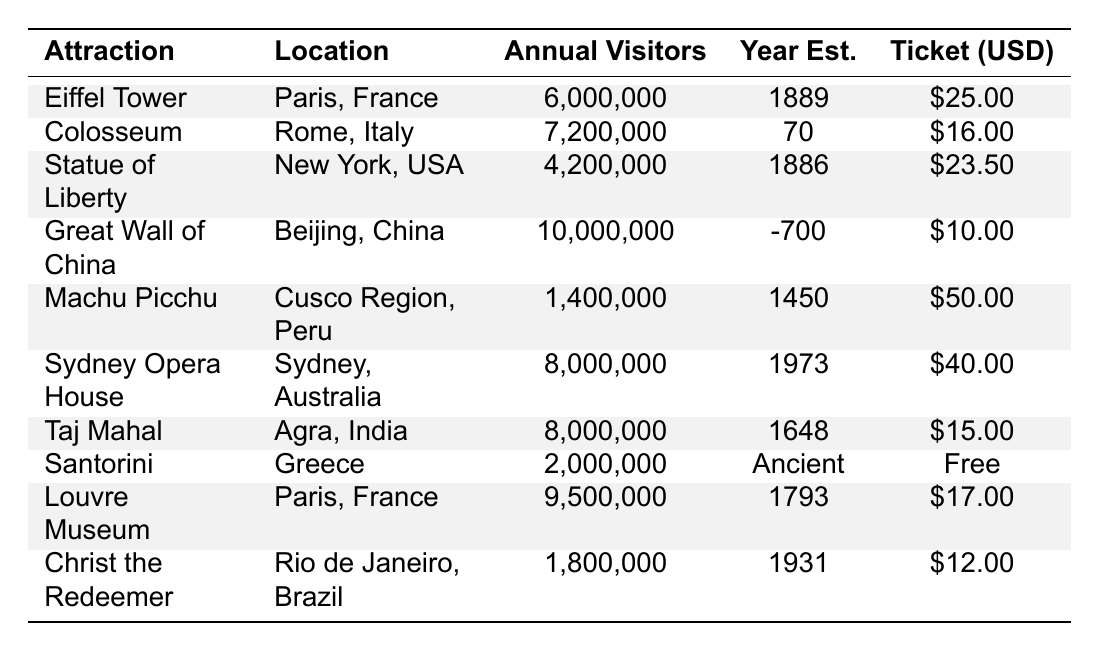What's the annual visitor count for the Great Wall of China? The annual visitors for the Great Wall of China is stated directly in the table as 10,000,000.
Answer: 10,000,000 Which attraction has the highest ticket price? By comparing the ticket prices listed in the table, Machu Picchu has the highest ticket price at $50.00.
Answer: $50.00 How many annual visitors do the Eiffel Tower and the Louvre Museum have combined? Adding the annual visitors of both attractions: 6,000,000 (Eiffel Tower) + 9,500,000 (Louvre Museum) = 15,500,000.
Answer: 15,500,000 Is it true that the Statue of Liberty has more visitors than Christ the Redeemer? Comparing the visitor counts, the Statue of Liberty has 4,200,000 visitors while Christ the Redeemer has 1,800,000, confirming the statement is true.
Answer: Yes What is the average ticket price for the attractions listed? Summing the ticket prices: $25 + $16 + $23.50 + $10 + $50 + $40 + $15 + $0 + $17 + $12 = $218.50. There are 10 attractions, so the average ticket price is $218.50 / 10 = $21.85.
Answer: $21.85 Which location has the most attractions listed in the table? Both Paris, France has the Eiffel Tower and the Louvre Museum, totaling 2 attractions, making it more than any other listed location.
Answer: Paris, France How many attractions have more than 5 million annual visitors? The attractions exceeding 5 million visitors are the Colosseum (7,200,000), Great Wall of China (10,000,000), Sydney Opera House (8,000,000), Taj Mahal (8,000,000), and Louvre Museum (9,500,000). Therefore, there are 5 attractions.
Answer: 5 Is the year established for the Santorini attraction listed as 'Ancient' valid? The data presented states the year established for Santorini as 'Ancient', which is a valid designation despite it being unconventional compared to the other specific years.
Answer: Yes How much less do annual visitors to Machu Picchu have compared to the Great Wall of China? Calculating the difference: 10,000,000 (Great Wall) - 1,400,000 (Machu Picchu) = 8,600,000.
Answer: 8,600,000 Which two attractions have the same number of annual visitors? Comparing the visitor counts, the Sydney Opera House and the Taj Mahal both have 8,000,000 annual visitors, making them a pair with the same count.
Answer: Sydney Opera House and Taj Mahal 